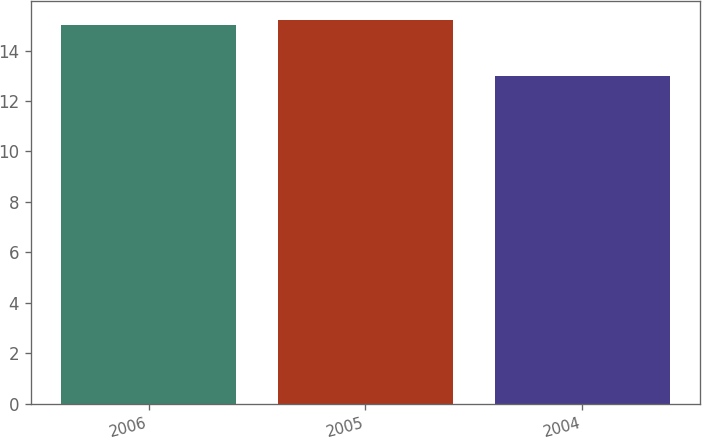Convert chart to OTSL. <chart><loc_0><loc_0><loc_500><loc_500><bar_chart><fcel>2006<fcel>2005<fcel>2004<nl><fcel>15<fcel>15.2<fcel>13<nl></chart> 